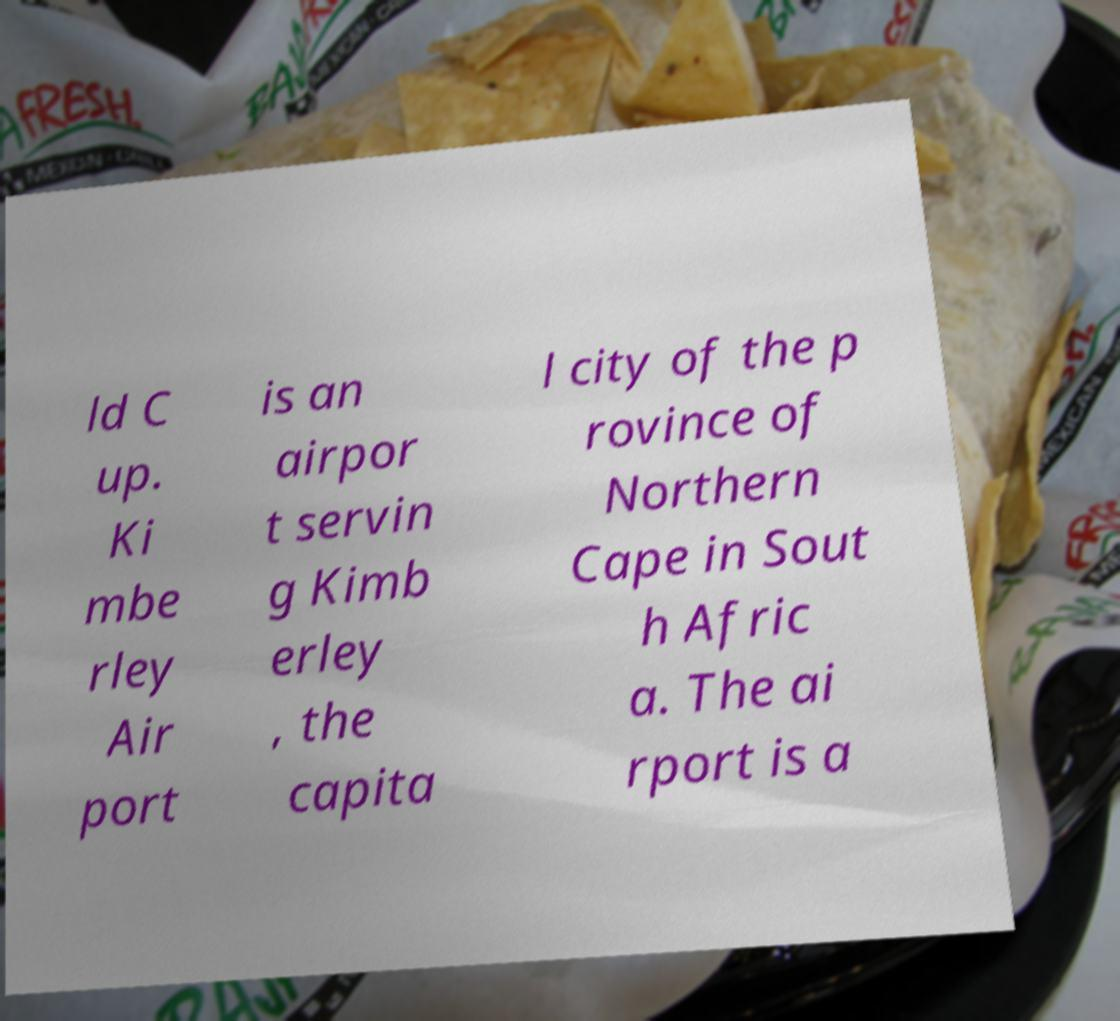Could you extract and type out the text from this image? ld C up. Ki mbe rley Air port is an airpor t servin g Kimb erley , the capita l city of the p rovince of Northern Cape in Sout h Afric a. The ai rport is a 